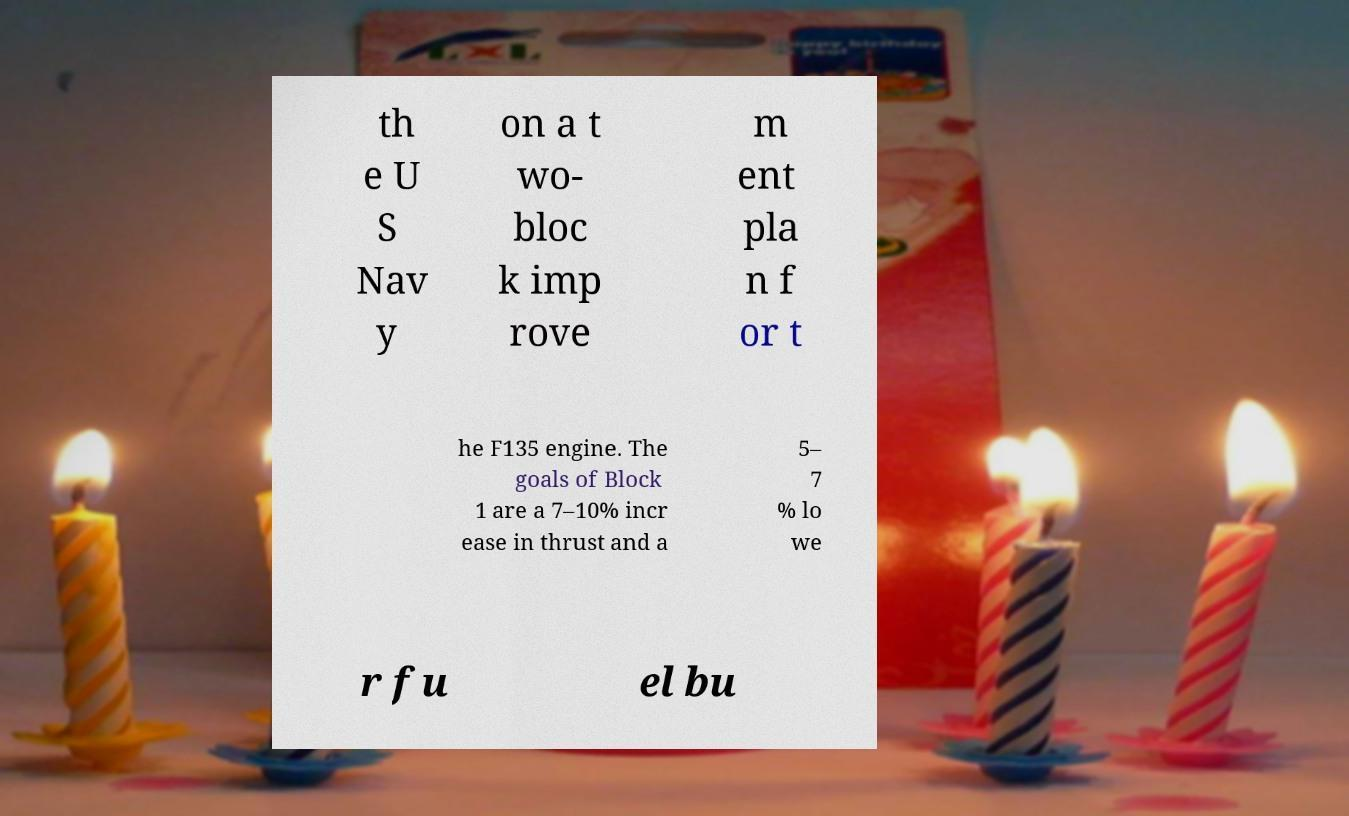Please identify and transcribe the text found in this image. th e U S Nav y on a t wo- bloc k imp rove m ent pla n f or t he F135 engine. The goals of Block 1 are a 7–10% incr ease in thrust and a 5– 7 % lo we r fu el bu 